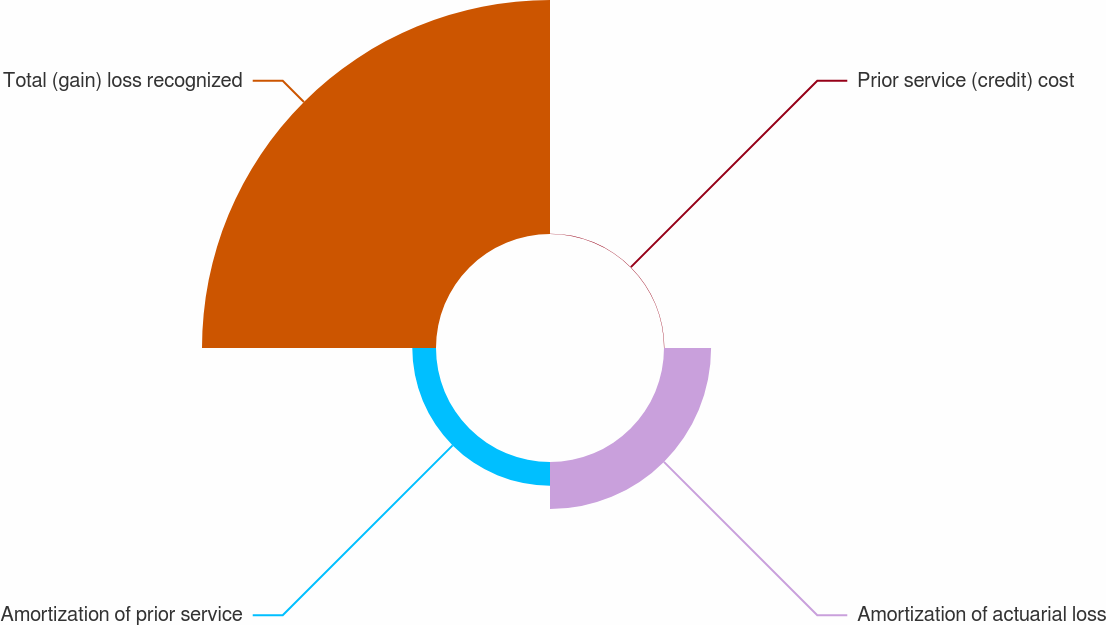<chart> <loc_0><loc_0><loc_500><loc_500><pie_chart><fcel>Prior service (credit) cost<fcel>Amortization of actuarial loss<fcel>Amortization of prior service<fcel>Total (gain) loss recognized<nl><fcel>0.12%<fcel>15.43%<fcel>7.77%<fcel>76.68%<nl></chart> 